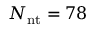Convert formula to latex. <formula><loc_0><loc_0><loc_500><loc_500>N _ { n t } = 7 8</formula> 